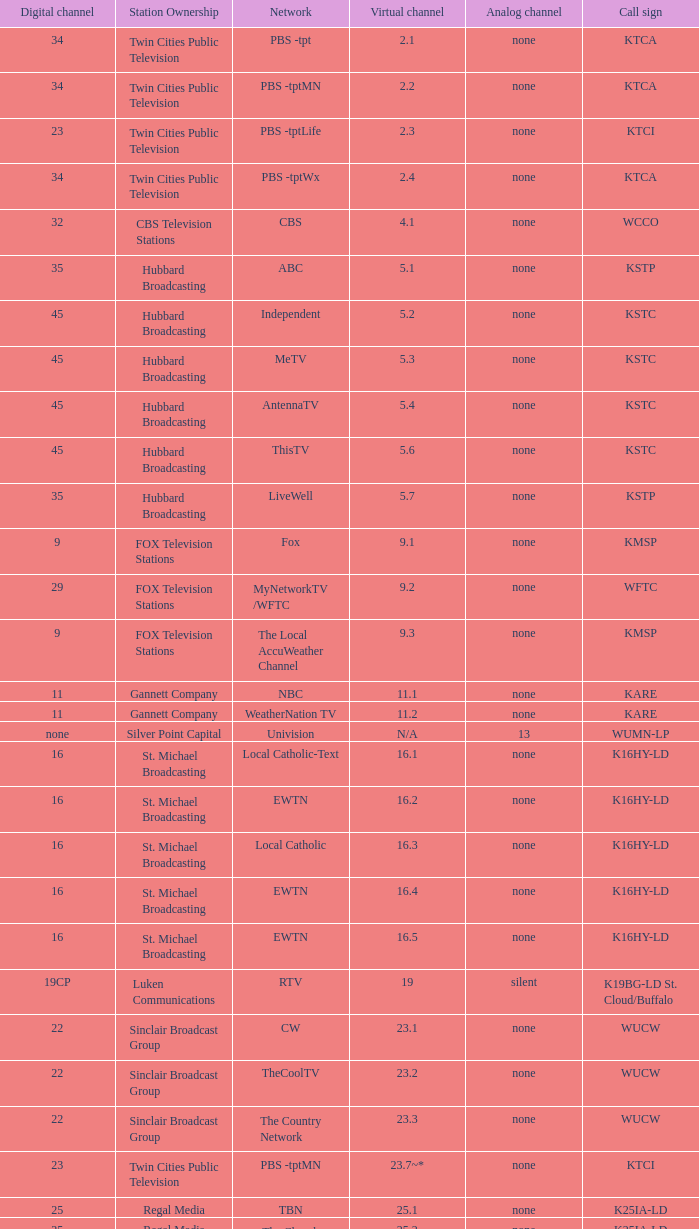Virtual channel of 16.5 has what call sign? K16HY-LD. 